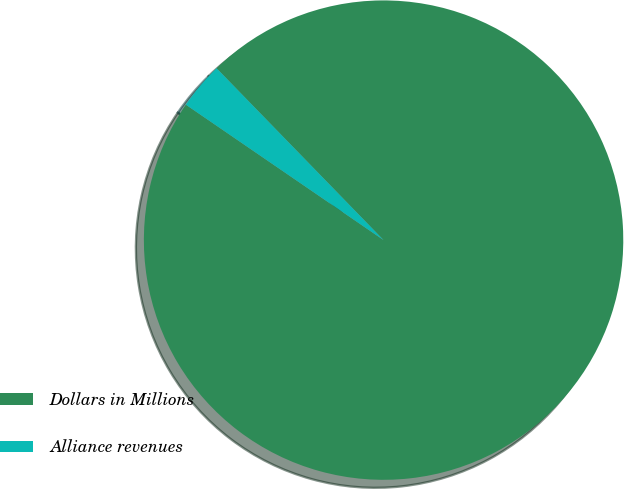Convert chart. <chart><loc_0><loc_0><loc_500><loc_500><pie_chart><fcel>Dollars in Millions<fcel>Alliance revenues<nl><fcel>96.83%<fcel>3.17%<nl></chart> 